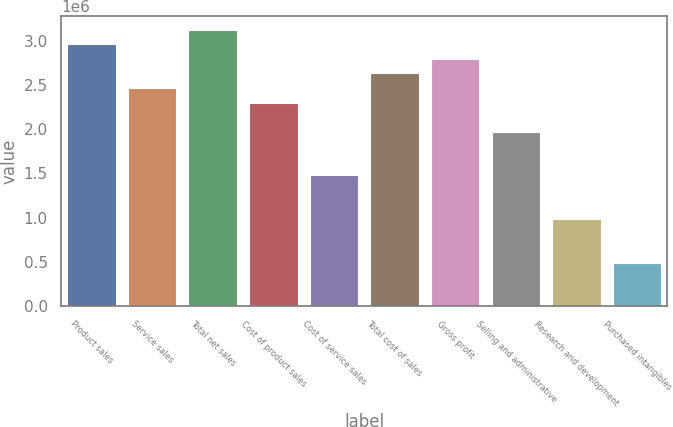Convert chart. <chart><loc_0><loc_0><loc_500><loc_500><bar_chart><fcel>Product sales<fcel>Service sales<fcel>Total net sales<fcel>Cost of product sales<fcel>Cost of service sales<fcel>Total cost of sales<fcel>Gross profit<fcel>Selling and administrative<fcel>Research and development<fcel>Purchased intangibles<nl><fcel>2.95806e+06<fcel>2.46505e+06<fcel>3.1224e+06<fcel>2.30072e+06<fcel>1.47903e+06<fcel>2.62939e+06<fcel>2.79373e+06<fcel>1.97204e+06<fcel>986024<fcel>493014<nl></chart> 